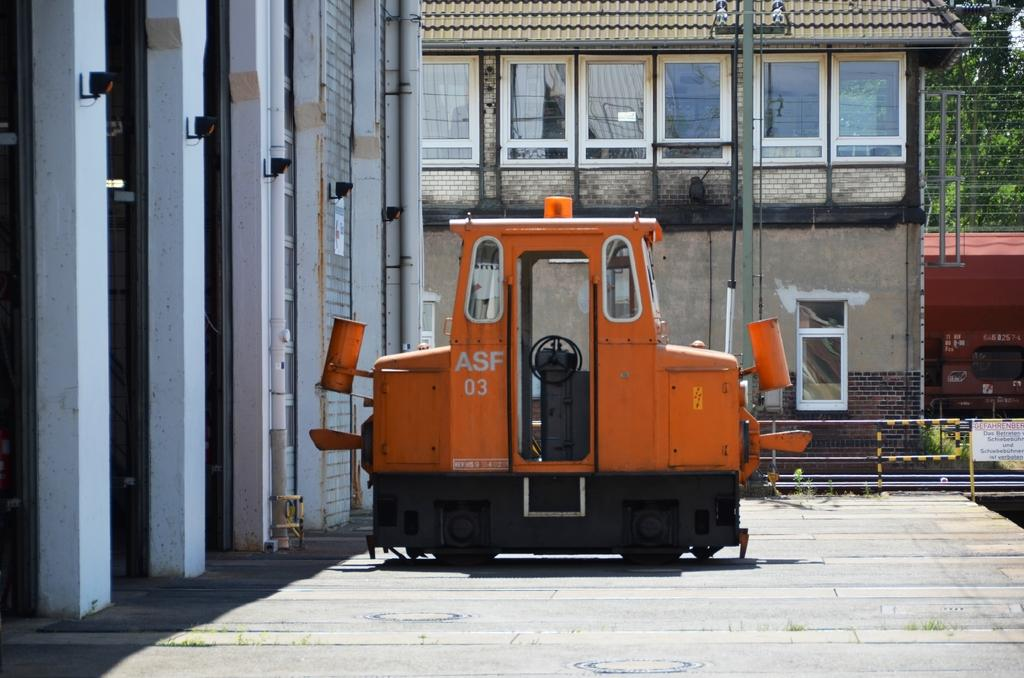What type of motor vehicle can be seen on the road in the image? The image does not specify the type of motor vehicle, but there is a motor vehicle on the road. What structures are present in the image? There are buildings in the image. What architectural features can be seen in the image? Windows and curtains are visible in the image. What infrastructure elements are present in the image? Pipelines and electric lights are present in the image. What type of vegetation is visible in the image? Trees are visible in the image. What part of the natural environment is visible in the image? The sky is visible in the image. Where is the queen sitting in the image? There is no queen present in the image. What type of girl can be seen playing with a patch in the image? There is no girl or patch present in the image. 